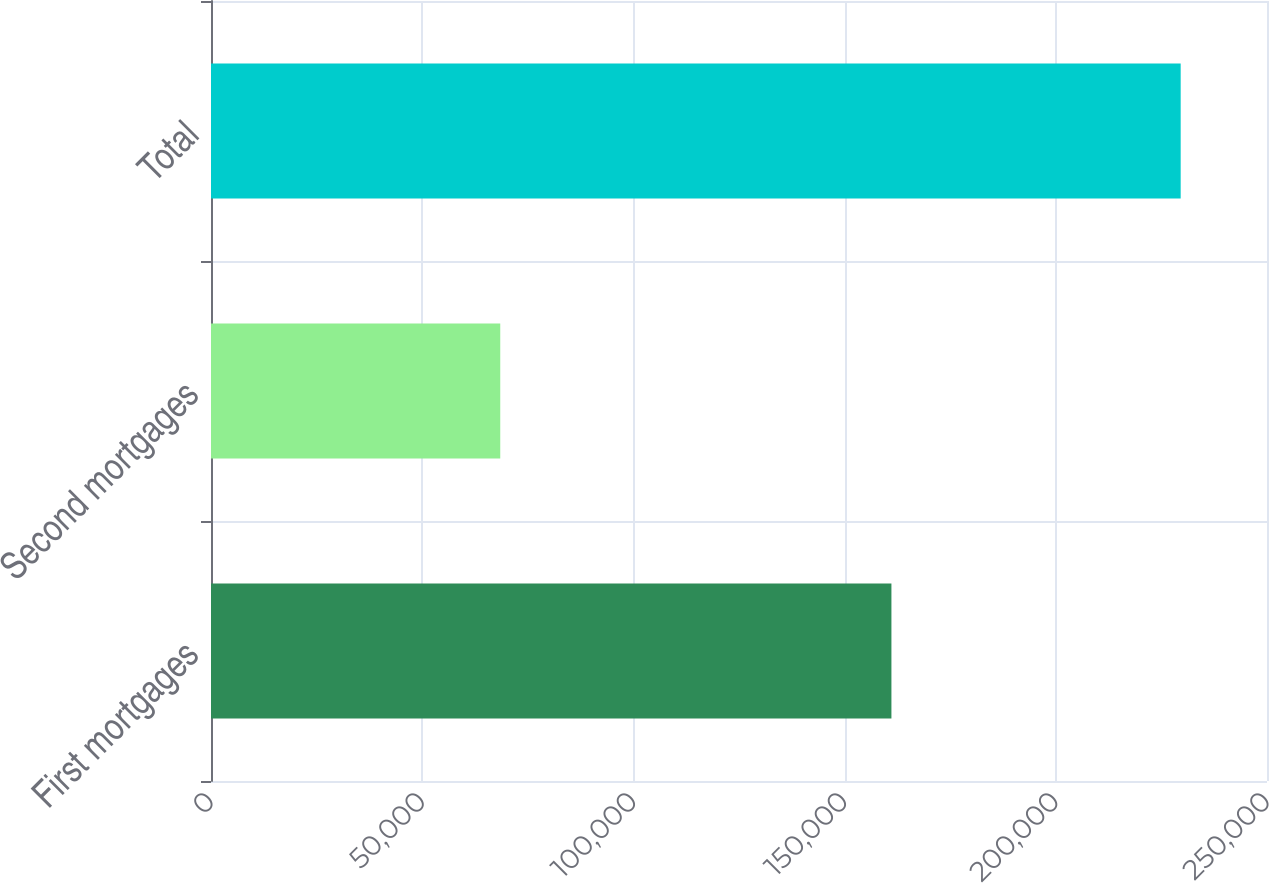<chart> <loc_0><loc_0><loc_500><loc_500><bar_chart><fcel>First mortgages<fcel>Second mortgages<fcel>Total<nl><fcel>161085<fcel>68479<fcel>229564<nl></chart> 